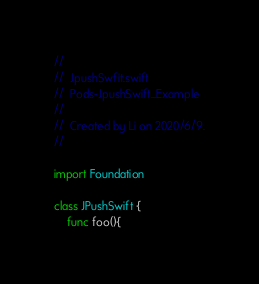Convert code to text. <code><loc_0><loc_0><loc_500><loc_500><_Swift_>//
//  JpushSwfit.swift
//  Pods-JpushSwift_Example
//
//  Created by Li on 2020/6/9.
//

import Foundation

class JPushSwift {
    func foo(){</code> 